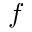<formula> <loc_0><loc_0><loc_500><loc_500>^ { f }</formula> 